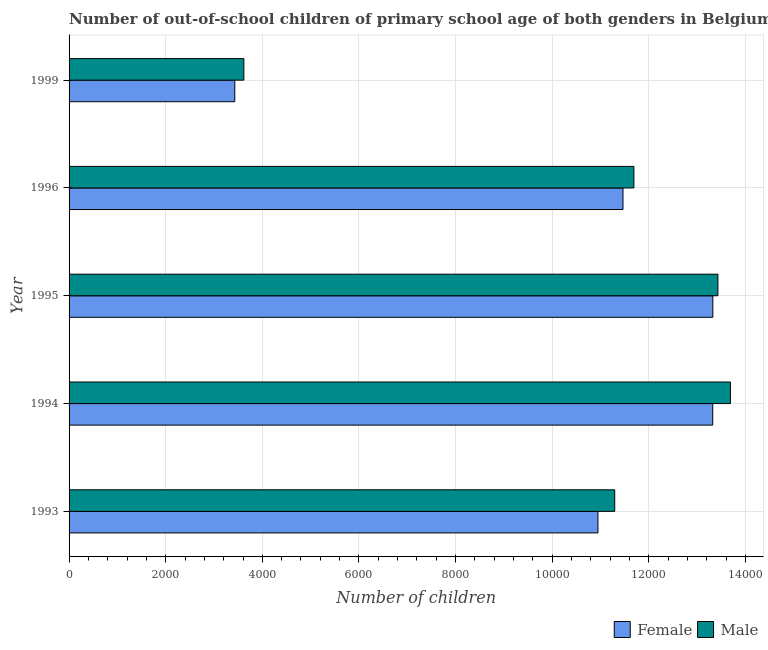How many different coloured bars are there?
Provide a short and direct response. 2. How many groups of bars are there?
Provide a succinct answer. 5. Are the number of bars per tick equal to the number of legend labels?
Ensure brevity in your answer.  Yes. Are the number of bars on each tick of the Y-axis equal?
Your response must be concise. Yes. What is the label of the 1st group of bars from the top?
Offer a very short reply. 1999. In how many cases, is the number of bars for a given year not equal to the number of legend labels?
Your response must be concise. 0. What is the number of male out-of-school students in 1995?
Provide a succinct answer. 1.34e+04. Across all years, what is the maximum number of male out-of-school students?
Your answer should be very brief. 1.37e+04. Across all years, what is the minimum number of male out-of-school students?
Make the answer very short. 3618. In which year was the number of male out-of-school students maximum?
Make the answer very short. 1994. In which year was the number of male out-of-school students minimum?
Offer a very short reply. 1999. What is the total number of male out-of-school students in the graph?
Keep it short and to the point. 5.37e+04. What is the difference between the number of female out-of-school students in 1996 and the number of male out-of-school students in 1999?
Keep it short and to the point. 7847. What is the average number of male out-of-school students per year?
Offer a very short reply. 1.07e+04. In the year 1996, what is the difference between the number of male out-of-school students and number of female out-of-school students?
Offer a terse response. 226. In how many years, is the number of female out-of-school students greater than 1600 ?
Your response must be concise. 5. What is the ratio of the number of female out-of-school students in 1993 to that in 1995?
Offer a terse response. 0.82. Is the number of male out-of-school students in 1994 less than that in 1995?
Provide a succinct answer. No. Is the difference between the number of female out-of-school students in 1995 and 1996 greater than the difference between the number of male out-of-school students in 1995 and 1996?
Provide a short and direct response. Yes. What is the difference between the highest and the second highest number of male out-of-school students?
Your answer should be very brief. 259. What is the difference between the highest and the lowest number of female out-of-school students?
Make the answer very short. 9895. In how many years, is the number of female out-of-school students greater than the average number of female out-of-school students taken over all years?
Provide a short and direct response. 4. What does the 1st bar from the top in 1995 represents?
Your answer should be compact. Male. How many bars are there?
Offer a terse response. 10. Are all the bars in the graph horizontal?
Keep it short and to the point. Yes. How many years are there in the graph?
Provide a short and direct response. 5. Does the graph contain grids?
Provide a short and direct response. Yes. Where does the legend appear in the graph?
Your answer should be compact. Bottom right. What is the title of the graph?
Your answer should be compact. Number of out-of-school children of primary school age of both genders in Belgium. Does "Sanitation services" appear as one of the legend labels in the graph?
Provide a succinct answer. No. What is the label or title of the X-axis?
Your answer should be compact. Number of children. What is the Number of children in Female in 1993?
Provide a succinct answer. 1.09e+04. What is the Number of children in Male in 1993?
Make the answer very short. 1.13e+04. What is the Number of children of Female in 1994?
Give a very brief answer. 1.33e+04. What is the Number of children in Male in 1994?
Offer a terse response. 1.37e+04. What is the Number of children in Female in 1995?
Offer a very short reply. 1.33e+04. What is the Number of children of Male in 1995?
Keep it short and to the point. 1.34e+04. What is the Number of children in Female in 1996?
Offer a very short reply. 1.15e+04. What is the Number of children of Male in 1996?
Ensure brevity in your answer.  1.17e+04. What is the Number of children of Female in 1999?
Offer a terse response. 3430. What is the Number of children of Male in 1999?
Your answer should be compact. 3618. Across all years, what is the maximum Number of children in Female?
Provide a succinct answer. 1.33e+04. Across all years, what is the maximum Number of children in Male?
Provide a succinct answer. 1.37e+04. Across all years, what is the minimum Number of children of Female?
Your answer should be very brief. 3430. Across all years, what is the minimum Number of children in Male?
Ensure brevity in your answer.  3618. What is the total Number of children of Female in the graph?
Make the answer very short. 5.25e+04. What is the total Number of children of Male in the graph?
Offer a very short reply. 5.37e+04. What is the difference between the Number of children of Female in 1993 and that in 1994?
Provide a short and direct response. -2376. What is the difference between the Number of children of Male in 1993 and that in 1994?
Provide a short and direct response. -2395. What is the difference between the Number of children in Female in 1993 and that in 1995?
Ensure brevity in your answer.  -2378. What is the difference between the Number of children in Male in 1993 and that in 1995?
Provide a succinct answer. -2136. What is the difference between the Number of children of Female in 1993 and that in 1996?
Give a very brief answer. -518. What is the difference between the Number of children in Male in 1993 and that in 1996?
Ensure brevity in your answer.  -397. What is the difference between the Number of children in Female in 1993 and that in 1999?
Your answer should be very brief. 7517. What is the difference between the Number of children in Male in 1993 and that in 1999?
Keep it short and to the point. 7676. What is the difference between the Number of children in Male in 1994 and that in 1995?
Make the answer very short. 259. What is the difference between the Number of children in Female in 1994 and that in 1996?
Make the answer very short. 1858. What is the difference between the Number of children in Male in 1994 and that in 1996?
Make the answer very short. 1998. What is the difference between the Number of children of Female in 1994 and that in 1999?
Your response must be concise. 9893. What is the difference between the Number of children of Male in 1994 and that in 1999?
Your answer should be compact. 1.01e+04. What is the difference between the Number of children in Female in 1995 and that in 1996?
Your answer should be compact. 1860. What is the difference between the Number of children of Male in 1995 and that in 1996?
Your answer should be very brief. 1739. What is the difference between the Number of children in Female in 1995 and that in 1999?
Make the answer very short. 9895. What is the difference between the Number of children in Male in 1995 and that in 1999?
Give a very brief answer. 9812. What is the difference between the Number of children of Female in 1996 and that in 1999?
Give a very brief answer. 8035. What is the difference between the Number of children of Male in 1996 and that in 1999?
Provide a short and direct response. 8073. What is the difference between the Number of children in Female in 1993 and the Number of children in Male in 1994?
Keep it short and to the point. -2742. What is the difference between the Number of children in Female in 1993 and the Number of children in Male in 1995?
Provide a succinct answer. -2483. What is the difference between the Number of children of Female in 1993 and the Number of children of Male in 1996?
Offer a very short reply. -744. What is the difference between the Number of children in Female in 1993 and the Number of children in Male in 1999?
Keep it short and to the point. 7329. What is the difference between the Number of children in Female in 1994 and the Number of children in Male in 1995?
Keep it short and to the point. -107. What is the difference between the Number of children in Female in 1994 and the Number of children in Male in 1996?
Your response must be concise. 1632. What is the difference between the Number of children in Female in 1994 and the Number of children in Male in 1999?
Your response must be concise. 9705. What is the difference between the Number of children in Female in 1995 and the Number of children in Male in 1996?
Offer a very short reply. 1634. What is the difference between the Number of children of Female in 1995 and the Number of children of Male in 1999?
Offer a terse response. 9707. What is the difference between the Number of children of Female in 1996 and the Number of children of Male in 1999?
Make the answer very short. 7847. What is the average Number of children in Female per year?
Make the answer very short. 1.05e+04. What is the average Number of children in Male per year?
Provide a short and direct response. 1.07e+04. In the year 1993, what is the difference between the Number of children in Female and Number of children in Male?
Make the answer very short. -347. In the year 1994, what is the difference between the Number of children in Female and Number of children in Male?
Make the answer very short. -366. In the year 1995, what is the difference between the Number of children in Female and Number of children in Male?
Your response must be concise. -105. In the year 1996, what is the difference between the Number of children of Female and Number of children of Male?
Ensure brevity in your answer.  -226. In the year 1999, what is the difference between the Number of children of Female and Number of children of Male?
Make the answer very short. -188. What is the ratio of the Number of children in Female in 1993 to that in 1994?
Ensure brevity in your answer.  0.82. What is the ratio of the Number of children in Male in 1993 to that in 1994?
Your answer should be very brief. 0.82. What is the ratio of the Number of children in Female in 1993 to that in 1995?
Keep it short and to the point. 0.82. What is the ratio of the Number of children of Male in 1993 to that in 1995?
Your response must be concise. 0.84. What is the ratio of the Number of children of Female in 1993 to that in 1996?
Offer a terse response. 0.95. What is the ratio of the Number of children in Female in 1993 to that in 1999?
Give a very brief answer. 3.19. What is the ratio of the Number of children of Male in 1993 to that in 1999?
Keep it short and to the point. 3.12. What is the ratio of the Number of children of Male in 1994 to that in 1995?
Ensure brevity in your answer.  1.02. What is the ratio of the Number of children of Female in 1994 to that in 1996?
Offer a very short reply. 1.16. What is the ratio of the Number of children of Male in 1994 to that in 1996?
Offer a very short reply. 1.17. What is the ratio of the Number of children of Female in 1994 to that in 1999?
Give a very brief answer. 3.88. What is the ratio of the Number of children in Male in 1994 to that in 1999?
Your answer should be very brief. 3.78. What is the ratio of the Number of children in Female in 1995 to that in 1996?
Make the answer very short. 1.16. What is the ratio of the Number of children of Male in 1995 to that in 1996?
Give a very brief answer. 1.15. What is the ratio of the Number of children of Female in 1995 to that in 1999?
Provide a succinct answer. 3.88. What is the ratio of the Number of children in Male in 1995 to that in 1999?
Provide a succinct answer. 3.71. What is the ratio of the Number of children in Female in 1996 to that in 1999?
Make the answer very short. 3.34. What is the ratio of the Number of children of Male in 1996 to that in 1999?
Your answer should be very brief. 3.23. What is the difference between the highest and the second highest Number of children of Male?
Your answer should be compact. 259. What is the difference between the highest and the lowest Number of children in Female?
Your answer should be very brief. 9895. What is the difference between the highest and the lowest Number of children in Male?
Your answer should be very brief. 1.01e+04. 